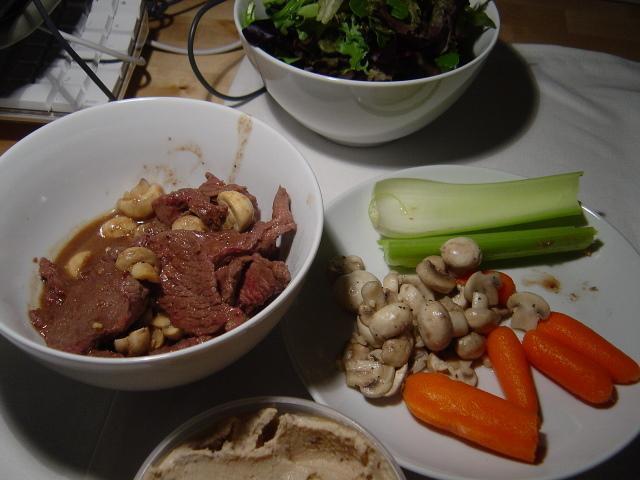How many slices of celery are there?
Give a very brief answer. 2. How many sushi rolls are shown?
Give a very brief answer. 0. How many carrots are there?
Give a very brief answer. 4. How many bowls are in the picture?
Give a very brief answer. 3. How many carrots are in the photo?
Give a very brief answer. 4. 